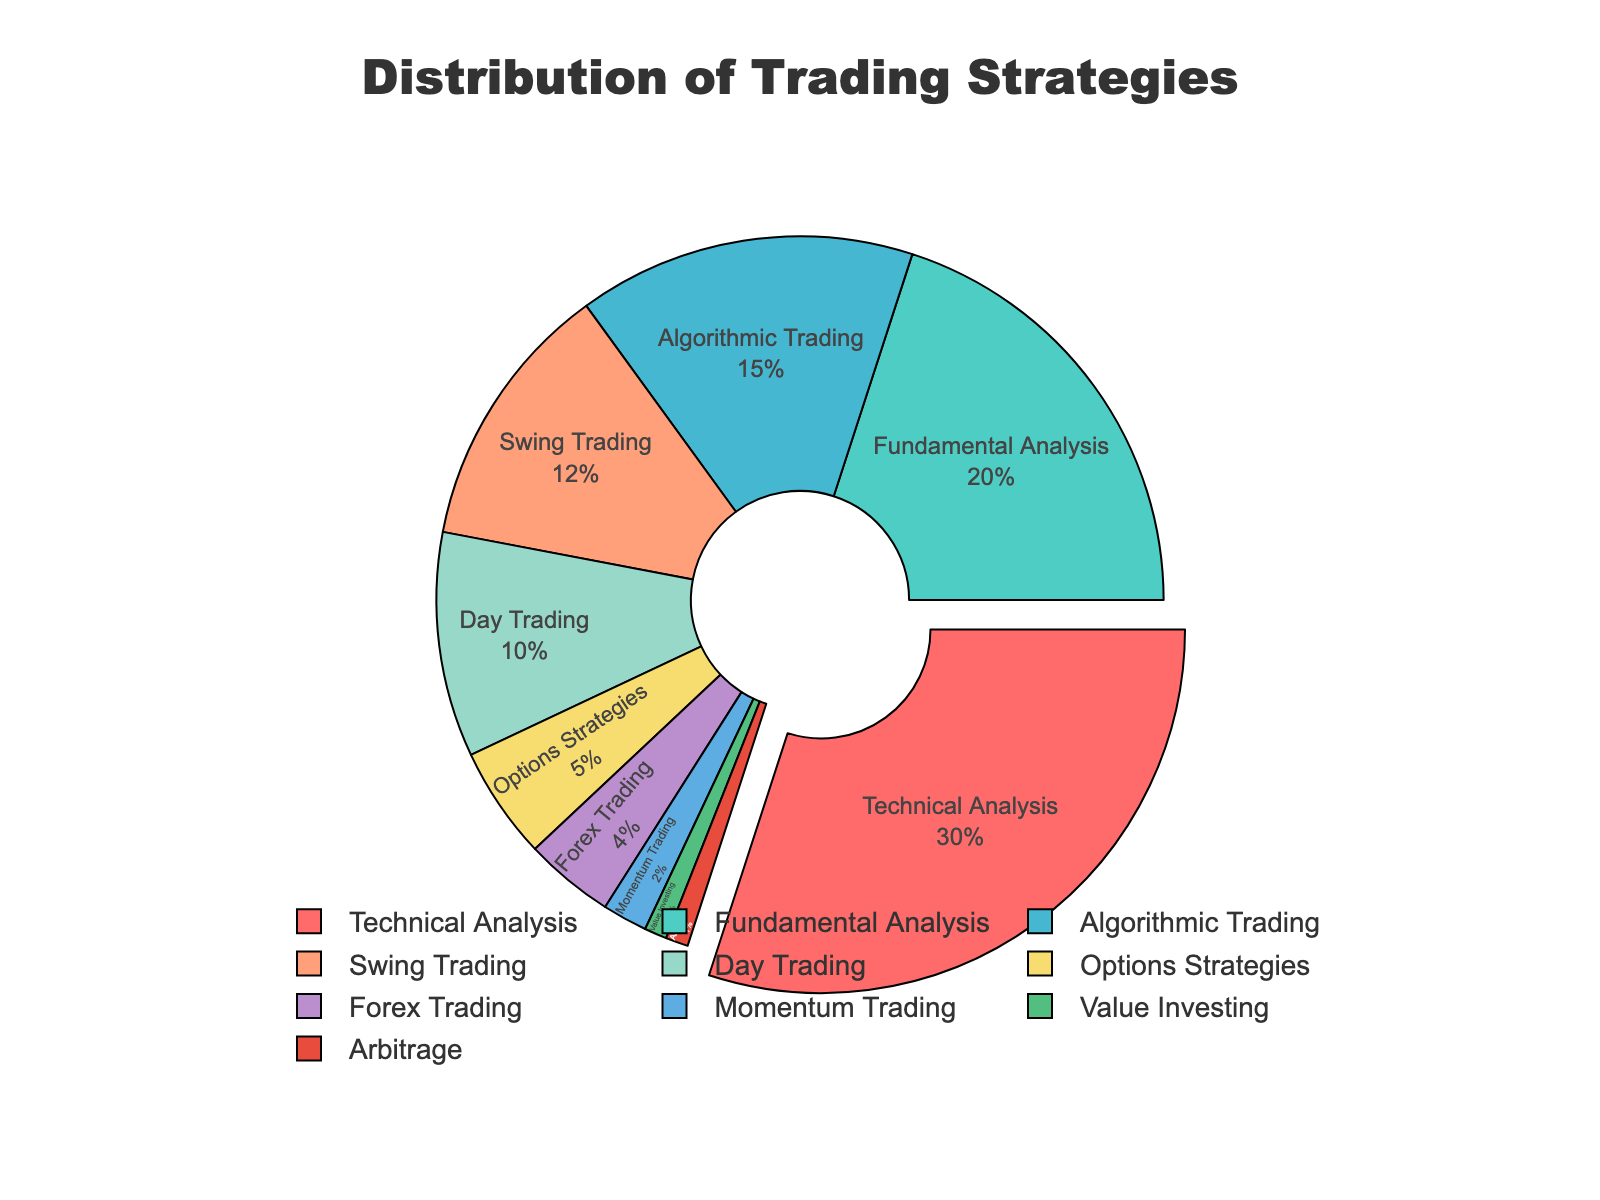What strategy has the highest percentage? The figure shows the percentage distribution of various trading strategies. The slice with the largest area corresponds to "Technical Analysis" and represents 30%. Therefore, Technical Analysis has the highest percentage.
Answer: Technical Analysis Which two strategies combined make up the majority of the distribution? The figure shows that "Technical Analysis" is 30% and "Fundamental Analysis" is 20%. Adding these two percentages, 30% + 20% = 50%, which is exactly half but still the majority in this context.
Answer: Technical Analysis and Fundamental Analysis What percentage of the strategies are categorized as either Options Strategies, Forex Trading, Momentum Trading, or Value Investing? According to the figure, Options Strategies is 5%, Forex Trading is 4%, Momentum Trading is 2%, and Value Investing is 1%. Adding them gives 5% + 4% + 2% + 1% = 12%.
Answer: 12% Which strategy is visually highlighted in the pie chart, and why? The strategy that is visually highlighted by being slightly pulled out is the one with the highest percentage, which is "Technical Analysis" with 30%. This highlighting aids in immediately drawing attention to the most significant slice of the pie.
Answer: Technical Analysis How does the combined percentage of Swing Trading and Day Trading compare to Algorithmic Trading? Swing Trading is 12%, and Day Trading is 10%. Combining these gives 12% + 10% = 22%. Algorithmic Trading is 15%. Comparing 22% to 15%, 22% is greater than 15%.
Answer: Swing Trading and Day Trading combined are greater How many strategies have a percentage less than 5%? Referring to the smallest slices, Forex Trading is 4%, Momentum Trading is 2%, Value Investing is 1%, and Arbitrage is 1%. Counting these, there are 4 strategies having a percentage less than 5%.
Answer: 4 Which strategy holds twice the percentage of Options Strategies? Options Strategies is listed as 5%. The figure shows that Day Trading has a percentage of 10%, which is exactly twice that of Options Strategies.
Answer: Day Trading What's the total percentage of strategies in the pie chart that fall under 10%? The strategies under 10% are Day Trading (10%), Options Strategies (5%), Forex Trading (4%), Momentum Trading (2%), Value Investing (1%), Arbitrage (1%). Adding these: 10% + 5% + 4% + 2% + 1% + 1% = 23%.
Answer: 23% What is the percentage difference between the highest and the lowest percentage strategies shown in the chart? The highest percentage is Technical Analysis at 30%, and the lowest percentages are Value Investing and Arbitrage both at 1%. The difference is 30% - 1% = 29%.
Answer: 29% 